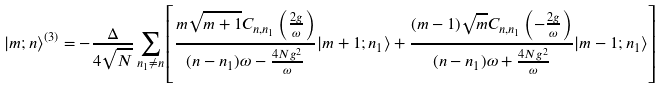<formula> <loc_0><loc_0><loc_500><loc_500>| m ; n \rangle ^ { ( 3 ) } = - \frac { \Delta } { 4 \sqrt { N } } \sum _ { n _ { 1 } \neq n } \left [ \frac { m \sqrt { m + 1 } C _ { n , n _ { 1 } } \left ( \frac { 2 g } { \omega } \right ) } { ( n - n _ { 1 } ) \omega - \frac { 4 N g ^ { 2 } } { \omega } } | m + 1 ; n _ { 1 } \rangle + \frac { ( m - 1 ) \sqrt { m } C _ { n , n _ { 1 } } \left ( - \frac { 2 g } { \omega } \right ) } { ( n - n _ { 1 } ) \omega + \frac { 4 N g ^ { 2 } } { \omega } } | m - 1 ; n _ { 1 } \rangle \right ]</formula> 